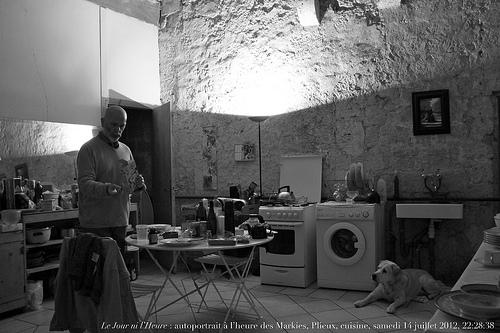Question: where is the dog?
Choices:
A. On the bed.
B. In the house.
C. Next to washer.
D. In the yard.
Answer with the letter. Answer: C Question: what color is the washer?
Choices:
A. Green.
B. Yellow.
C. Gray.
D. White.
Answer with the letter. Answer: D Question: who is the dog looking at?
Choices:
A. Owner.
B. The old man.
C. Child.
D. Actor on tv.
Answer with the letter. Answer: B Question: what gender is this person?
Choices:
A. Female.
B. Man.
C. Woman.
D. Male.
Answer with the letter. Answer: D 